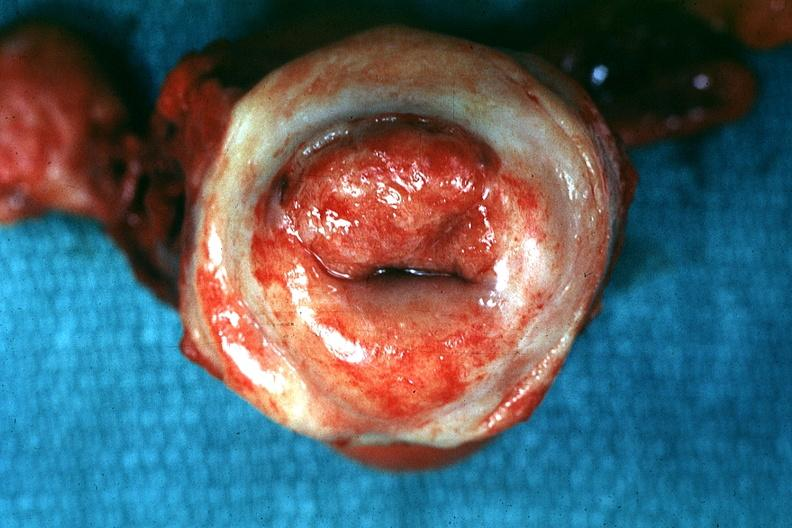s inflamed exocervix said to be invasive carcinoma?
Answer the question using a single word or phrase. Yes 